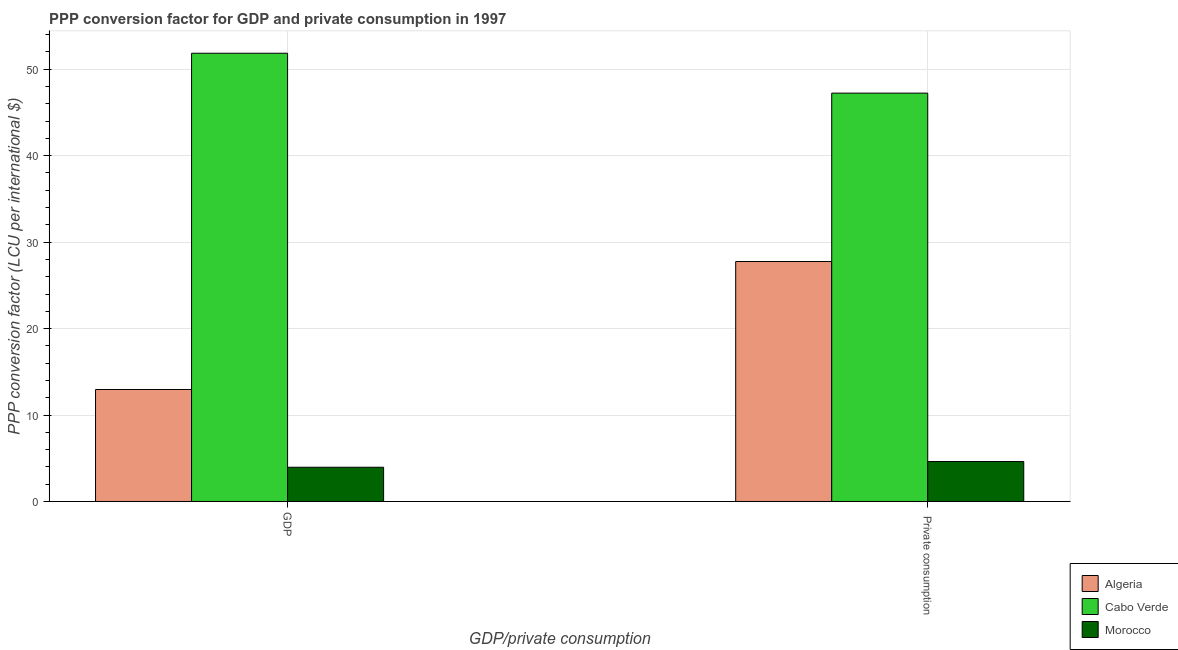How many groups of bars are there?
Provide a succinct answer. 2. Are the number of bars per tick equal to the number of legend labels?
Offer a very short reply. Yes. Are the number of bars on each tick of the X-axis equal?
Ensure brevity in your answer.  Yes. How many bars are there on the 1st tick from the left?
Your answer should be very brief. 3. What is the label of the 1st group of bars from the left?
Provide a short and direct response. GDP. What is the ppp conversion factor for private consumption in Morocco?
Your answer should be compact. 4.62. Across all countries, what is the maximum ppp conversion factor for gdp?
Give a very brief answer. 51.86. Across all countries, what is the minimum ppp conversion factor for gdp?
Make the answer very short. 3.96. In which country was the ppp conversion factor for gdp maximum?
Ensure brevity in your answer.  Cabo Verde. In which country was the ppp conversion factor for private consumption minimum?
Your answer should be compact. Morocco. What is the total ppp conversion factor for gdp in the graph?
Give a very brief answer. 68.77. What is the difference between the ppp conversion factor for gdp in Algeria and that in Cabo Verde?
Your response must be concise. -38.9. What is the difference between the ppp conversion factor for private consumption in Algeria and the ppp conversion factor for gdp in Cabo Verde?
Offer a very short reply. -24.1. What is the average ppp conversion factor for private consumption per country?
Offer a very short reply. 26.54. What is the difference between the ppp conversion factor for gdp and ppp conversion factor for private consumption in Cabo Verde?
Your answer should be compact. 4.62. In how many countries, is the ppp conversion factor for gdp greater than 18 LCU?
Provide a short and direct response. 1. What is the ratio of the ppp conversion factor for gdp in Morocco to that in Cabo Verde?
Your answer should be very brief. 0.08. Is the ppp conversion factor for private consumption in Algeria less than that in Cabo Verde?
Your answer should be compact. Yes. What does the 2nd bar from the left in GDP represents?
Provide a short and direct response. Cabo Verde. What does the 3rd bar from the right in GDP represents?
Give a very brief answer. Algeria. How many bars are there?
Your answer should be very brief. 6. How many countries are there in the graph?
Provide a short and direct response. 3. Where does the legend appear in the graph?
Offer a terse response. Bottom right. How are the legend labels stacked?
Your answer should be very brief. Vertical. What is the title of the graph?
Offer a terse response. PPP conversion factor for GDP and private consumption in 1997. What is the label or title of the X-axis?
Make the answer very short. GDP/private consumption. What is the label or title of the Y-axis?
Provide a succinct answer. PPP conversion factor (LCU per international $). What is the PPP conversion factor (LCU per international $) in Algeria in GDP?
Ensure brevity in your answer.  12.95. What is the PPP conversion factor (LCU per international $) in Cabo Verde in GDP?
Keep it short and to the point. 51.86. What is the PPP conversion factor (LCU per international $) of Morocco in GDP?
Offer a very short reply. 3.96. What is the PPP conversion factor (LCU per international $) of Algeria in  Private consumption?
Provide a succinct answer. 27.76. What is the PPP conversion factor (LCU per international $) of Cabo Verde in  Private consumption?
Provide a short and direct response. 47.24. What is the PPP conversion factor (LCU per international $) of Morocco in  Private consumption?
Give a very brief answer. 4.62. Across all GDP/private consumption, what is the maximum PPP conversion factor (LCU per international $) in Algeria?
Offer a terse response. 27.76. Across all GDP/private consumption, what is the maximum PPP conversion factor (LCU per international $) of Cabo Verde?
Give a very brief answer. 51.86. Across all GDP/private consumption, what is the maximum PPP conversion factor (LCU per international $) in Morocco?
Keep it short and to the point. 4.62. Across all GDP/private consumption, what is the minimum PPP conversion factor (LCU per international $) in Algeria?
Your response must be concise. 12.95. Across all GDP/private consumption, what is the minimum PPP conversion factor (LCU per international $) in Cabo Verde?
Offer a terse response. 47.24. Across all GDP/private consumption, what is the minimum PPP conversion factor (LCU per international $) of Morocco?
Offer a terse response. 3.96. What is the total PPP conversion factor (LCU per international $) in Algeria in the graph?
Offer a very short reply. 40.71. What is the total PPP conversion factor (LCU per international $) of Cabo Verde in the graph?
Your answer should be very brief. 99.09. What is the total PPP conversion factor (LCU per international $) in Morocco in the graph?
Make the answer very short. 8.58. What is the difference between the PPP conversion factor (LCU per international $) in Algeria in GDP and that in  Private consumption?
Give a very brief answer. -14.8. What is the difference between the PPP conversion factor (LCU per international $) in Cabo Verde in GDP and that in  Private consumption?
Provide a short and direct response. 4.62. What is the difference between the PPP conversion factor (LCU per international $) of Morocco in GDP and that in  Private consumption?
Keep it short and to the point. -0.66. What is the difference between the PPP conversion factor (LCU per international $) of Algeria in GDP and the PPP conversion factor (LCU per international $) of Cabo Verde in  Private consumption?
Your response must be concise. -34.29. What is the difference between the PPP conversion factor (LCU per international $) of Algeria in GDP and the PPP conversion factor (LCU per international $) of Morocco in  Private consumption?
Your answer should be compact. 8.33. What is the difference between the PPP conversion factor (LCU per international $) in Cabo Verde in GDP and the PPP conversion factor (LCU per international $) in Morocco in  Private consumption?
Ensure brevity in your answer.  47.24. What is the average PPP conversion factor (LCU per international $) of Algeria per GDP/private consumption?
Your answer should be compact. 20.36. What is the average PPP conversion factor (LCU per international $) of Cabo Verde per GDP/private consumption?
Ensure brevity in your answer.  49.55. What is the average PPP conversion factor (LCU per international $) of Morocco per GDP/private consumption?
Your answer should be very brief. 4.29. What is the difference between the PPP conversion factor (LCU per international $) in Algeria and PPP conversion factor (LCU per international $) in Cabo Verde in GDP?
Keep it short and to the point. -38.9. What is the difference between the PPP conversion factor (LCU per international $) in Algeria and PPP conversion factor (LCU per international $) in Morocco in GDP?
Offer a very short reply. 9. What is the difference between the PPP conversion factor (LCU per international $) of Cabo Verde and PPP conversion factor (LCU per international $) of Morocco in GDP?
Provide a short and direct response. 47.9. What is the difference between the PPP conversion factor (LCU per international $) of Algeria and PPP conversion factor (LCU per international $) of Cabo Verde in  Private consumption?
Make the answer very short. -19.48. What is the difference between the PPP conversion factor (LCU per international $) in Algeria and PPP conversion factor (LCU per international $) in Morocco in  Private consumption?
Provide a succinct answer. 23.14. What is the difference between the PPP conversion factor (LCU per international $) in Cabo Verde and PPP conversion factor (LCU per international $) in Morocco in  Private consumption?
Provide a short and direct response. 42.62. What is the ratio of the PPP conversion factor (LCU per international $) in Algeria in GDP to that in  Private consumption?
Your answer should be compact. 0.47. What is the ratio of the PPP conversion factor (LCU per international $) of Cabo Verde in GDP to that in  Private consumption?
Your answer should be compact. 1.1. What is the ratio of the PPP conversion factor (LCU per international $) of Morocco in GDP to that in  Private consumption?
Provide a succinct answer. 0.86. What is the difference between the highest and the second highest PPP conversion factor (LCU per international $) in Algeria?
Offer a very short reply. 14.8. What is the difference between the highest and the second highest PPP conversion factor (LCU per international $) of Cabo Verde?
Your answer should be very brief. 4.62. What is the difference between the highest and the second highest PPP conversion factor (LCU per international $) in Morocco?
Your answer should be compact. 0.66. What is the difference between the highest and the lowest PPP conversion factor (LCU per international $) of Algeria?
Give a very brief answer. 14.8. What is the difference between the highest and the lowest PPP conversion factor (LCU per international $) of Cabo Verde?
Provide a succinct answer. 4.62. What is the difference between the highest and the lowest PPP conversion factor (LCU per international $) in Morocco?
Provide a short and direct response. 0.66. 